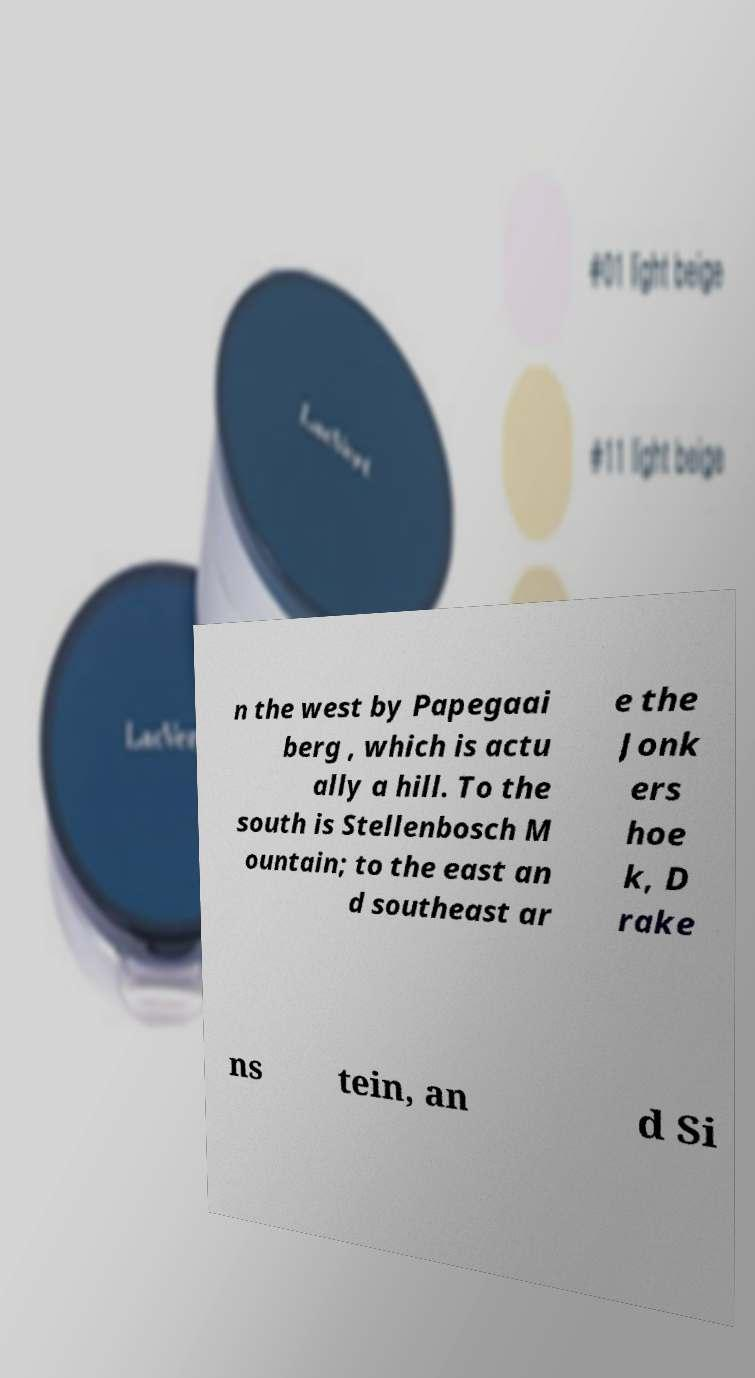For documentation purposes, I need the text within this image transcribed. Could you provide that? n the west by Papegaai berg , which is actu ally a hill. To the south is Stellenbosch M ountain; to the east an d southeast ar e the Jonk ers hoe k, D rake ns tein, an d Si 